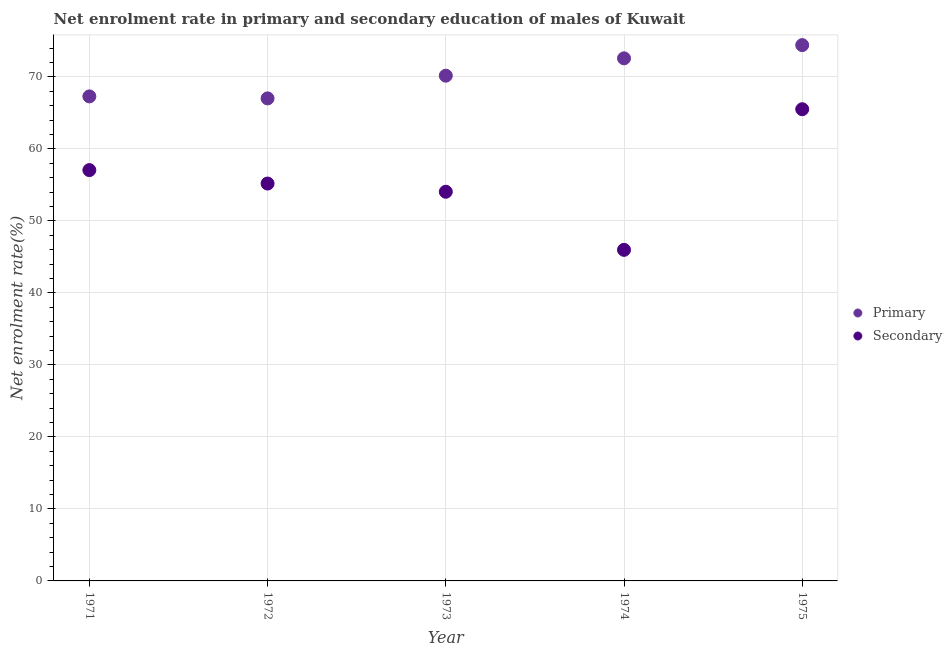What is the enrollment rate in secondary education in 1975?
Offer a terse response. 65.51. Across all years, what is the maximum enrollment rate in primary education?
Ensure brevity in your answer.  74.41. Across all years, what is the minimum enrollment rate in secondary education?
Your answer should be compact. 45.98. In which year was the enrollment rate in secondary education maximum?
Make the answer very short. 1975. In which year was the enrollment rate in primary education minimum?
Keep it short and to the point. 1972. What is the total enrollment rate in primary education in the graph?
Ensure brevity in your answer.  351.45. What is the difference between the enrollment rate in secondary education in 1972 and that in 1974?
Make the answer very short. 9.21. What is the difference between the enrollment rate in primary education in 1975 and the enrollment rate in secondary education in 1974?
Your response must be concise. 28.43. What is the average enrollment rate in secondary education per year?
Provide a succinct answer. 55.55. In the year 1973, what is the difference between the enrollment rate in secondary education and enrollment rate in primary education?
Provide a short and direct response. -16.12. What is the ratio of the enrollment rate in primary education in 1972 to that in 1974?
Your answer should be compact. 0.92. What is the difference between the highest and the second highest enrollment rate in secondary education?
Offer a very short reply. 8.45. What is the difference between the highest and the lowest enrollment rate in primary education?
Your answer should be compact. 7.4. Is the sum of the enrollment rate in primary education in 1972 and 1975 greater than the maximum enrollment rate in secondary education across all years?
Your response must be concise. Yes. Does the enrollment rate in secondary education monotonically increase over the years?
Give a very brief answer. No. Is the enrollment rate in secondary education strictly greater than the enrollment rate in primary education over the years?
Offer a very short reply. No. Does the graph contain any zero values?
Keep it short and to the point. No. Where does the legend appear in the graph?
Your answer should be compact. Center right. How many legend labels are there?
Ensure brevity in your answer.  2. How are the legend labels stacked?
Offer a very short reply. Vertical. What is the title of the graph?
Your answer should be very brief. Net enrolment rate in primary and secondary education of males of Kuwait. What is the label or title of the Y-axis?
Make the answer very short. Net enrolment rate(%). What is the Net enrolment rate(%) of Primary in 1971?
Your answer should be very brief. 67.29. What is the Net enrolment rate(%) of Secondary in 1971?
Ensure brevity in your answer.  57.05. What is the Net enrolment rate(%) of Primary in 1972?
Your answer should be very brief. 67.01. What is the Net enrolment rate(%) in Secondary in 1972?
Keep it short and to the point. 55.18. What is the Net enrolment rate(%) of Primary in 1973?
Your answer should be very brief. 70.16. What is the Net enrolment rate(%) in Secondary in 1973?
Offer a very short reply. 54.05. What is the Net enrolment rate(%) of Primary in 1974?
Your response must be concise. 72.58. What is the Net enrolment rate(%) of Secondary in 1974?
Your response must be concise. 45.98. What is the Net enrolment rate(%) in Primary in 1975?
Offer a terse response. 74.41. What is the Net enrolment rate(%) of Secondary in 1975?
Provide a succinct answer. 65.51. Across all years, what is the maximum Net enrolment rate(%) in Primary?
Ensure brevity in your answer.  74.41. Across all years, what is the maximum Net enrolment rate(%) of Secondary?
Provide a short and direct response. 65.51. Across all years, what is the minimum Net enrolment rate(%) in Primary?
Keep it short and to the point. 67.01. Across all years, what is the minimum Net enrolment rate(%) in Secondary?
Provide a short and direct response. 45.98. What is the total Net enrolment rate(%) in Primary in the graph?
Ensure brevity in your answer.  351.45. What is the total Net enrolment rate(%) of Secondary in the graph?
Your answer should be compact. 277.77. What is the difference between the Net enrolment rate(%) of Primary in 1971 and that in 1972?
Your answer should be very brief. 0.28. What is the difference between the Net enrolment rate(%) of Secondary in 1971 and that in 1972?
Provide a succinct answer. 1.87. What is the difference between the Net enrolment rate(%) in Primary in 1971 and that in 1973?
Ensure brevity in your answer.  -2.88. What is the difference between the Net enrolment rate(%) of Secondary in 1971 and that in 1973?
Ensure brevity in your answer.  3.01. What is the difference between the Net enrolment rate(%) of Primary in 1971 and that in 1974?
Give a very brief answer. -5.29. What is the difference between the Net enrolment rate(%) of Secondary in 1971 and that in 1974?
Keep it short and to the point. 11.07. What is the difference between the Net enrolment rate(%) of Primary in 1971 and that in 1975?
Make the answer very short. -7.12. What is the difference between the Net enrolment rate(%) of Secondary in 1971 and that in 1975?
Your answer should be very brief. -8.45. What is the difference between the Net enrolment rate(%) in Primary in 1972 and that in 1973?
Provide a short and direct response. -3.15. What is the difference between the Net enrolment rate(%) in Secondary in 1972 and that in 1973?
Your response must be concise. 1.14. What is the difference between the Net enrolment rate(%) in Primary in 1972 and that in 1974?
Provide a short and direct response. -5.56. What is the difference between the Net enrolment rate(%) in Secondary in 1972 and that in 1974?
Your answer should be compact. 9.21. What is the difference between the Net enrolment rate(%) of Primary in 1972 and that in 1975?
Your response must be concise. -7.4. What is the difference between the Net enrolment rate(%) in Secondary in 1972 and that in 1975?
Your answer should be very brief. -10.32. What is the difference between the Net enrolment rate(%) of Primary in 1973 and that in 1974?
Keep it short and to the point. -2.41. What is the difference between the Net enrolment rate(%) of Secondary in 1973 and that in 1974?
Offer a terse response. 8.07. What is the difference between the Net enrolment rate(%) of Primary in 1973 and that in 1975?
Make the answer very short. -4.25. What is the difference between the Net enrolment rate(%) in Secondary in 1973 and that in 1975?
Provide a short and direct response. -11.46. What is the difference between the Net enrolment rate(%) in Primary in 1974 and that in 1975?
Your answer should be very brief. -1.83. What is the difference between the Net enrolment rate(%) in Secondary in 1974 and that in 1975?
Your response must be concise. -19.53. What is the difference between the Net enrolment rate(%) of Primary in 1971 and the Net enrolment rate(%) of Secondary in 1972?
Keep it short and to the point. 12.1. What is the difference between the Net enrolment rate(%) in Primary in 1971 and the Net enrolment rate(%) in Secondary in 1973?
Provide a short and direct response. 13.24. What is the difference between the Net enrolment rate(%) of Primary in 1971 and the Net enrolment rate(%) of Secondary in 1974?
Offer a very short reply. 21.31. What is the difference between the Net enrolment rate(%) of Primary in 1971 and the Net enrolment rate(%) of Secondary in 1975?
Provide a succinct answer. 1.78. What is the difference between the Net enrolment rate(%) of Primary in 1972 and the Net enrolment rate(%) of Secondary in 1973?
Give a very brief answer. 12.97. What is the difference between the Net enrolment rate(%) of Primary in 1972 and the Net enrolment rate(%) of Secondary in 1974?
Give a very brief answer. 21.03. What is the difference between the Net enrolment rate(%) of Primary in 1972 and the Net enrolment rate(%) of Secondary in 1975?
Offer a terse response. 1.51. What is the difference between the Net enrolment rate(%) in Primary in 1973 and the Net enrolment rate(%) in Secondary in 1974?
Your response must be concise. 24.19. What is the difference between the Net enrolment rate(%) of Primary in 1973 and the Net enrolment rate(%) of Secondary in 1975?
Keep it short and to the point. 4.66. What is the difference between the Net enrolment rate(%) of Primary in 1974 and the Net enrolment rate(%) of Secondary in 1975?
Provide a short and direct response. 7.07. What is the average Net enrolment rate(%) in Primary per year?
Make the answer very short. 70.29. What is the average Net enrolment rate(%) of Secondary per year?
Ensure brevity in your answer.  55.55. In the year 1971, what is the difference between the Net enrolment rate(%) of Primary and Net enrolment rate(%) of Secondary?
Your answer should be very brief. 10.24. In the year 1972, what is the difference between the Net enrolment rate(%) of Primary and Net enrolment rate(%) of Secondary?
Offer a very short reply. 11.83. In the year 1973, what is the difference between the Net enrolment rate(%) in Primary and Net enrolment rate(%) in Secondary?
Your answer should be compact. 16.12. In the year 1974, what is the difference between the Net enrolment rate(%) in Primary and Net enrolment rate(%) in Secondary?
Your answer should be compact. 26.6. In the year 1975, what is the difference between the Net enrolment rate(%) in Primary and Net enrolment rate(%) in Secondary?
Make the answer very short. 8.9. What is the ratio of the Net enrolment rate(%) in Secondary in 1971 to that in 1972?
Ensure brevity in your answer.  1.03. What is the ratio of the Net enrolment rate(%) of Secondary in 1971 to that in 1973?
Your response must be concise. 1.06. What is the ratio of the Net enrolment rate(%) of Primary in 1971 to that in 1974?
Provide a short and direct response. 0.93. What is the ratio of the Net enrolment rate(%) in Secondary in 1971 to that in 1974?
Make the answer very short. 1.24. What is the ratio of the Net enrolment rate(%) of Primary in 1971 to that in 1975?
Your answer should be very brief. 0.9. What is the ratio of the Net enrolment rate(%) of Secondary in 1971 to that in 1975?
Ensure brevity in your answer.  0.87. What is the ratio of the Net enrolment rate(%) of Primary in 1972 to that in 1973?
Give a very brief answer. 0.96. What is the ratio of the Net enrolment rate(%) of Secondary in 1972 to that in 1973?
Ensure brevity in your answer.  1.02. What is the ratio of the Net enrolment rate(%) in Primary in 1972 to that in 1974?
Offer a terse response. 0.92. What is the ratio of the Net enrolment rate(%) in Secondary in 1972 to that in 1974?
Offer a terse response. 1.2. What is the ratio of the Net enrolment rate(%) in Primary in 1972 to that in 1975?
Provide a succinct answer. 0.9. What is the ratio of the Net enrolment rate(%) of Secondary in 1972 to that in 1975?
Give a very brief answer. 0.84. What is the ratio of the Net enrolment rate(%) of Primary in 1973 to that in 1974?
Provide a short and direct response. 0.97. What is the ratio of the Net enrolment rate(%) of Secondary in 1973 to that in 1974?
Offer a very short reply. 1.18. What is the ratio of the Net enrolment rate(%) in Primary in 1973 to that in 1975?
Your answer should be very brief. 0.94. What is the ratio of the Net enrolment rate(%) in Secondary in 1973 to that in 1975?
Give a very brief answer. 0.82. What is the ratio of the Net enrolment rate(%) in Primary in 1974 to that in 1975?
Keep it short and to the point. 0.98. What is the ratio of the Net enrolment rate(%) of Secondary in 1974 to that in 1975?
Your response must be concise. 0.7. What is the difference between the highest and the second highest Net enrolment rate(%) in Primary?
Provide a short and direct response. 1.83. What is the difference between the highest and the second highest Net enrolment rate(%) of Secondary?
Provide a short and direct response. 8.45. What is the difference between the highest and the lowest Net enrolment rate(%) of Primary?
Offer a very short reply. 7.4. What is the difference between the highest and the lowest Net enrolment rate(%) in Secondary?
Your answer should be compact. 19.53. 